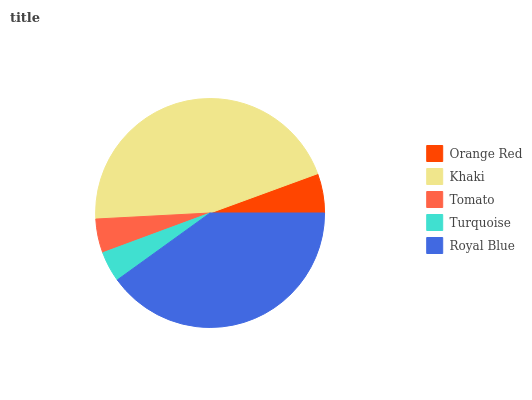Is Turquoise the minimum?
Answer yes or no. Yes. Is Khaki the maximum?
Answer yes or no. Yes. Is Tomato the minimum?
Answer yes or no. No. Is Tomato the maximum?
Answer yes or no. No. Is Khaki greater than Tomato?
Answer yes or no. Yes. Is Tomato less than Khaki?
Answer yes or no. Yes. Is Tomato greater than Khaki?
Answer yes or no. No. Is Khaki less than Tomato?
Answer yes or no. No. Is Orange Red the high median?
Answer yes or no. Yes. Is Orange Red the low median?
Answer yes or no. Yes. Is Tomato the high median?
Answer yes or no. No. Is Royal Blue the low median?
Answer yes or no. No. 